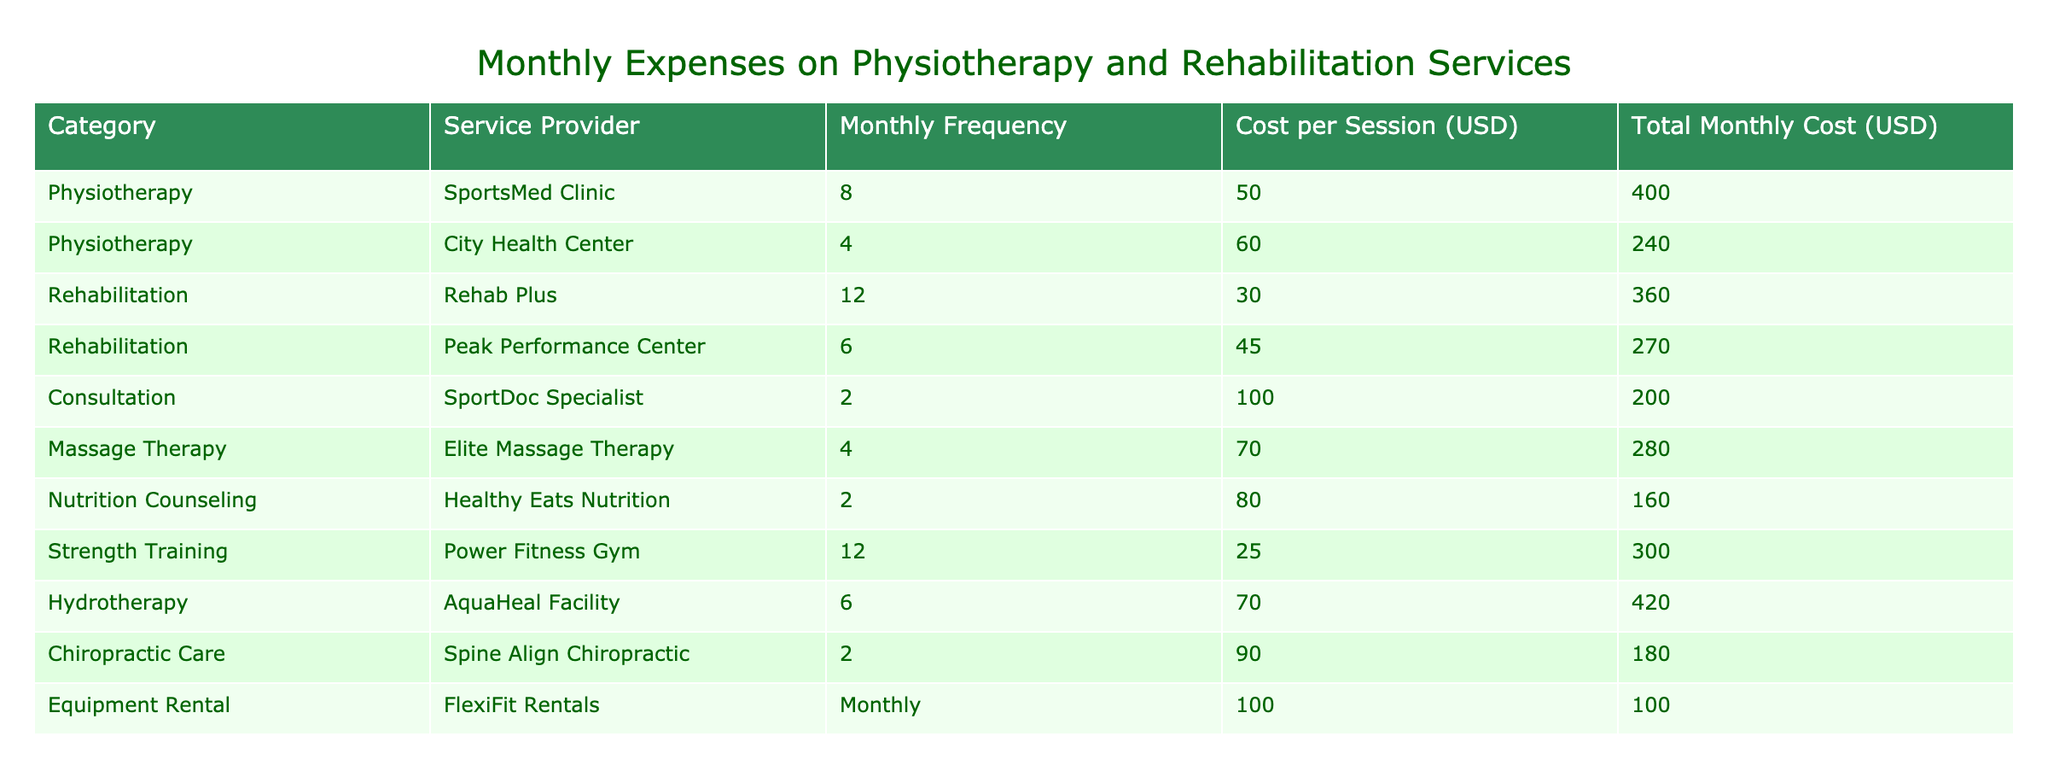What's the total monthly cost for physiotherapy at the SportsMed Clinic? The table shows that the cost per session at SportsMed Clinic is 50 USD, and the frequency is 8 times a month. Therefore, the total monthly cost is calculated as 50 * 8 = 400 USD.
Answer: 400 USD What is the cost per session for rehabilitation at Rehab Plus? According to the table, the cost per session for rehabilitation services at Rehab Plus is listed as 30 USD.
Answer: 30 USD Is the cost for hydrotherapy higher than the cost for strength training? The total monthly cost for hydrotherapy is 420 USD, while the total monthly cost for strength training is 300 USD. Therefore, hydrotherapy is indeed more expensive than strength training, making the answer yes.
Answer: Yes Which service provider has the highest total monthly cost? By reviewing the total monthly costs for each service provider, we see that hydrotherapy at AquaHeal Facility has the highest total monthly cost at 420 USD. We compare this with other costs: SportsMed Clinic (400 USD), Rehab Plus (360 USD), and so on. AquaHeal Facility has the highest.
Answer: AquaHeal Facility What is the difference in total monthly costs between chiropractic care and nutrition counseling? Chiropractic care costs 180 USD monthly while nutrition counseling costs 160 USD. To find the difference, we subtract: 180 - 160 = 20 USD.
Answer: 20 USD What is the average cost per session for the rehabilitation services listed in the table? There are two rehabilitation services: Rehab Plus (30 USD per session) and Peak Performance Center (45 USD per session). Adding these gives 30 + 45 = 75 USD. Dividing by 2, we find the average cost per session is 75 / 2 = 37.5 USD.
Answer: 37.5 USD Does the total cost for massage therapy exceed the total cost for consultations? The total cost for massage therapy is 280 USD, while the total cost for consultations is 200 USD. Since 280 is greater than 200, we conclude that yes, the total cost for massage therapy exceeds that of consultations.
Answer: Yes What is the combined total monthly cost for all strength training and rehabilitation services? The total cost for rehabilitation (Rehab Plus 360 USD and Peak Performance Center 270 USD) is 360 + 270 = 630 USD. The total cost for strength training is 300 USD, so the combined total is 630 + 300 = 930 USD.
Answer: 930 USD 